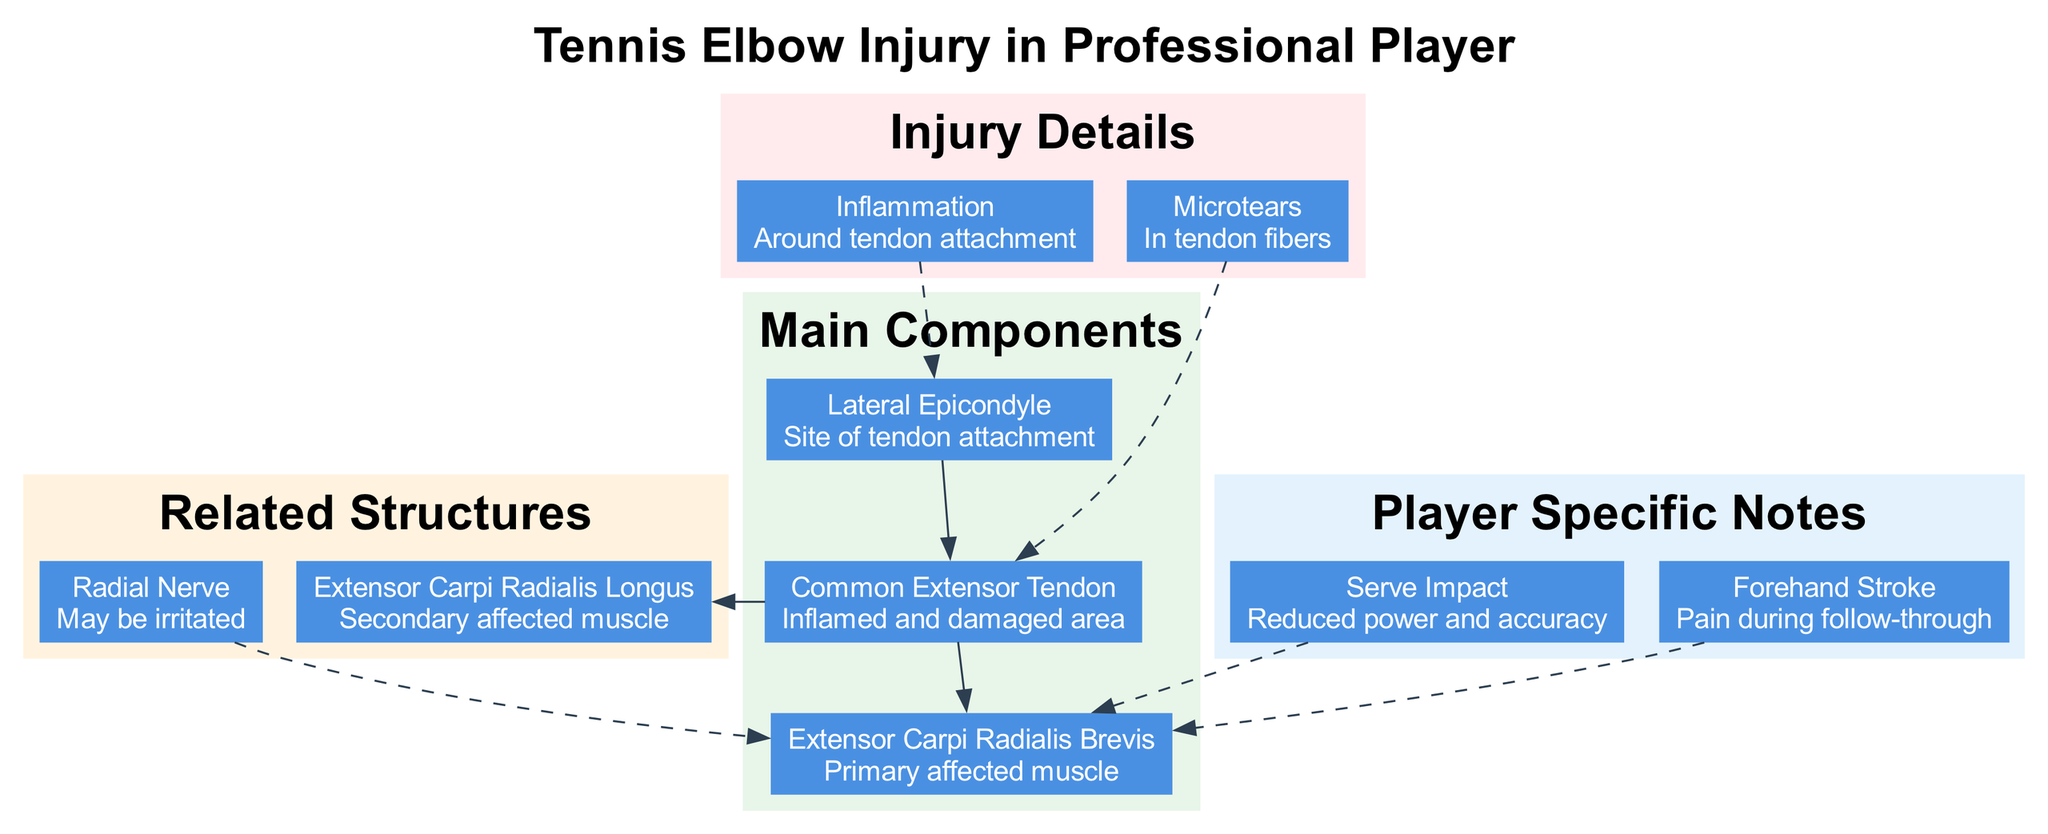What is the primary affected muscle in a tennis elbow injury? The diagram indicates that the primary affected muscle is "Extensor Carpi Radialis Brevis", as noted in the main components.
Answer: Extensor Carpi Radialis Brevis How many main components are shown in the diagram? Upon reviewing the main components section, there are three listed: Lateral Epicondyle, Extensor Carpi Radialis Brevis, and Common Extensor Tendon.
Answer: 3 What is the relationship between the "Lateral Epicondyle" and "Common Extensor Tendon"? The diagram illustrates that the "Lateral Epicondyle" connects to the "Common Extensor Tendon" through a direct edge, signifying a connection or relationship in terms of tendon attachment.
Answer: Connects Which structure may be irritated in a tennis elbow injury? The related structures section mentions that the "Radial Nerve" may be irritated in this injury context.
Answer: Radial Nerve What injury detail describes "Infection" around the tendon attachment? The diagram presents "Inflammation" as the injury detail concerning the area around the tendon attachment, rather than "Infection."
Answer: Inflammation What effect does a serve impact have on the affected muscle? The player-specific notes clarify that the "Serve Impact" results in reduced power and accuracy, affecting the performance of the affected muscle during a serve.
Answer: Reduced power and accuracy What are microtears in the context of a tennis elbow injury? The diagram uses "Microtears" to describe the condition of the tendon fibers that occur as part of the injury, indicating microscopic damage.
Answer: In tendon fibers Which muscle is considered a secondary affected muscle? Upon examination of the related structures, "Extensor Carpi Radialis Longus" is identified as the secondary affected muscle in the context of the tennis elbow injury.
Answer: Extensor Carpi Radialis Longus How does "Forehand Stroke" relate to the affected muscle? The notes indicate that during a "Forehand Stroke," there is pain experienced during the follow-through, directly relating to the affected muscle, which reflects the impact of the injury on stroke mechanics.
Answer: Pain during follow-through 